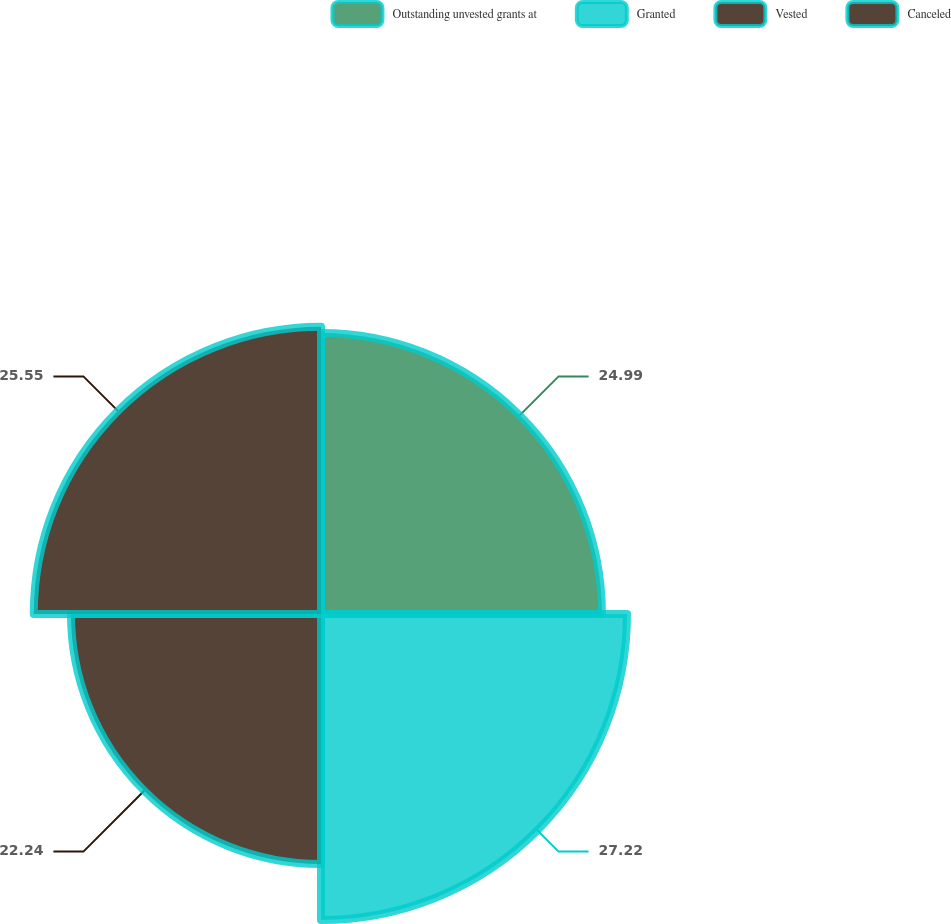Convert chart to OTSL. <chart><loc_0><loc_0><loc_500><loc_500><pie_chart><fcel>Outstanding unvested grants at<fcel>Granted<fcel>Vested<fcel>Canceled<nl><fcel>24.99%<fcel>27.22%<fcel>22.24%<fcel>25.55%<nl></chart> 